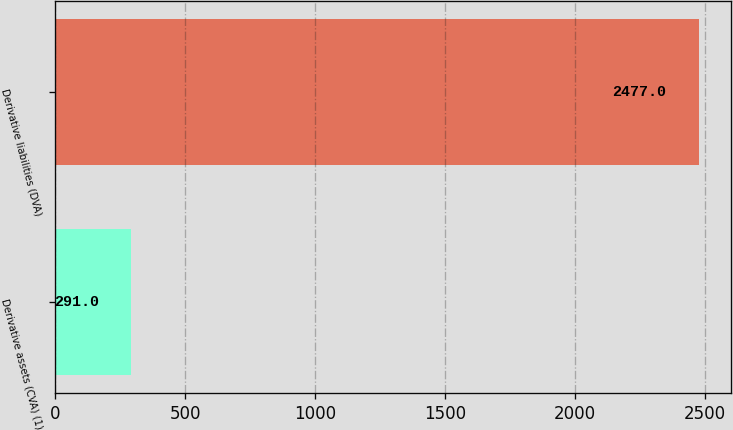<chart> <loc_0><loc_0><loc_500><loc_500><bar_chart><fcel>Derivative assets (CVA) (1)<fcel>Derivative liabilities (DVA)<nl><fcel>291<fcel>2477<nl></chart> 